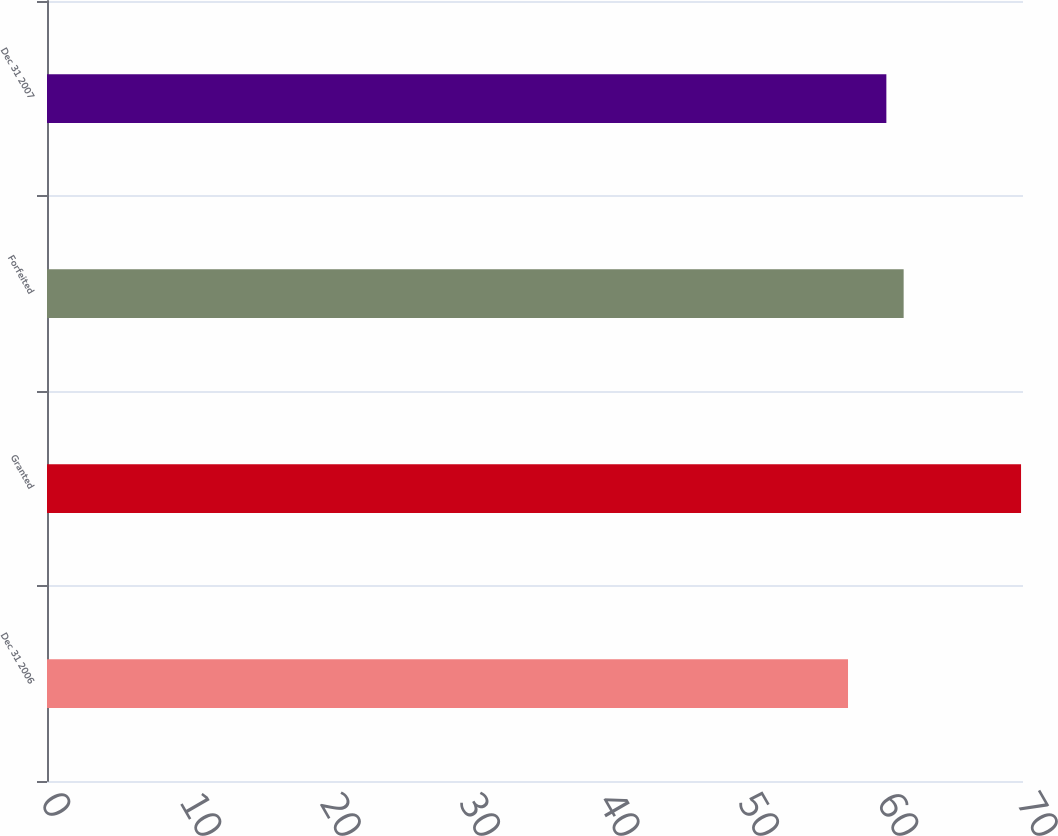Convert chart to OTSL. <chart><loc_0><loc_0><loc_500><loc_500><bar_chart><fcel>Dec 31 2006<fcel>Granted<fcel>Forfeited<fcel>Dec 31 2007<nl><fcel>57.45<fcel>69.86<fcel>61.44<fcel>60.2<nl></chart> 